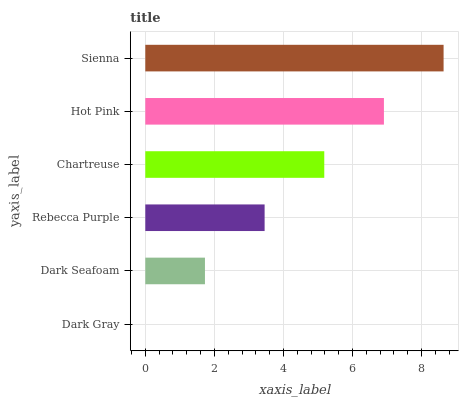Is Dark Gray the minimum?
Answer yes or no. Yes. Is Sienna the maximum?
Answer yes or no. Yes. Is Dark Seafoam the minimum?
Answer yes or no. No. Is Dark Seafoam the maximum?
Answer yes or no. No. Is Dark Seafoam greater than Dark Gray?
Answer yes or no. Yes. Is Dark Gray less than Dark Seafoam?
Answer yes or no. Yes. Is Dark Gray greater than Dark Seafoam?
Answer yes or no. No. Is Dark Seafoam less than Dark Gray?
Answer yes or no. No. Is Chartreuse the high median?
Answer yes or no. Yes. Is Rebecca Purple the low median?
Answer yes or no. Yes. Is Hot Pink the high median?
Answer yes or no. No. Is Dark Gray the low median?
Answer yes or no. No. 